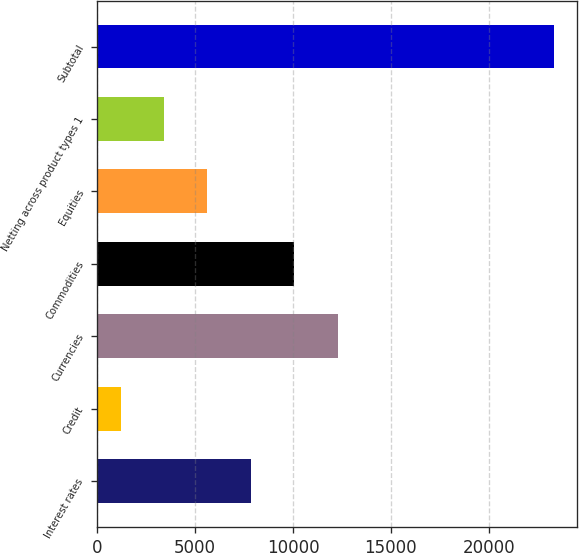<chart> <loc_0><loc_0><loc_500><loc_500><bar_chart><fcel>Interest rates<fcel>Credit<fcel>Currencies<fcel>Commodities<fcel>Equities<fcel>Netting across product types 1<fcel>Subtotal<nl><fcel>7846.2<fcel>1200<fcel>12277<fcel>10061.6<fcel>5630.8<fcel>3415.4<fcel>23354<nl></chart> 